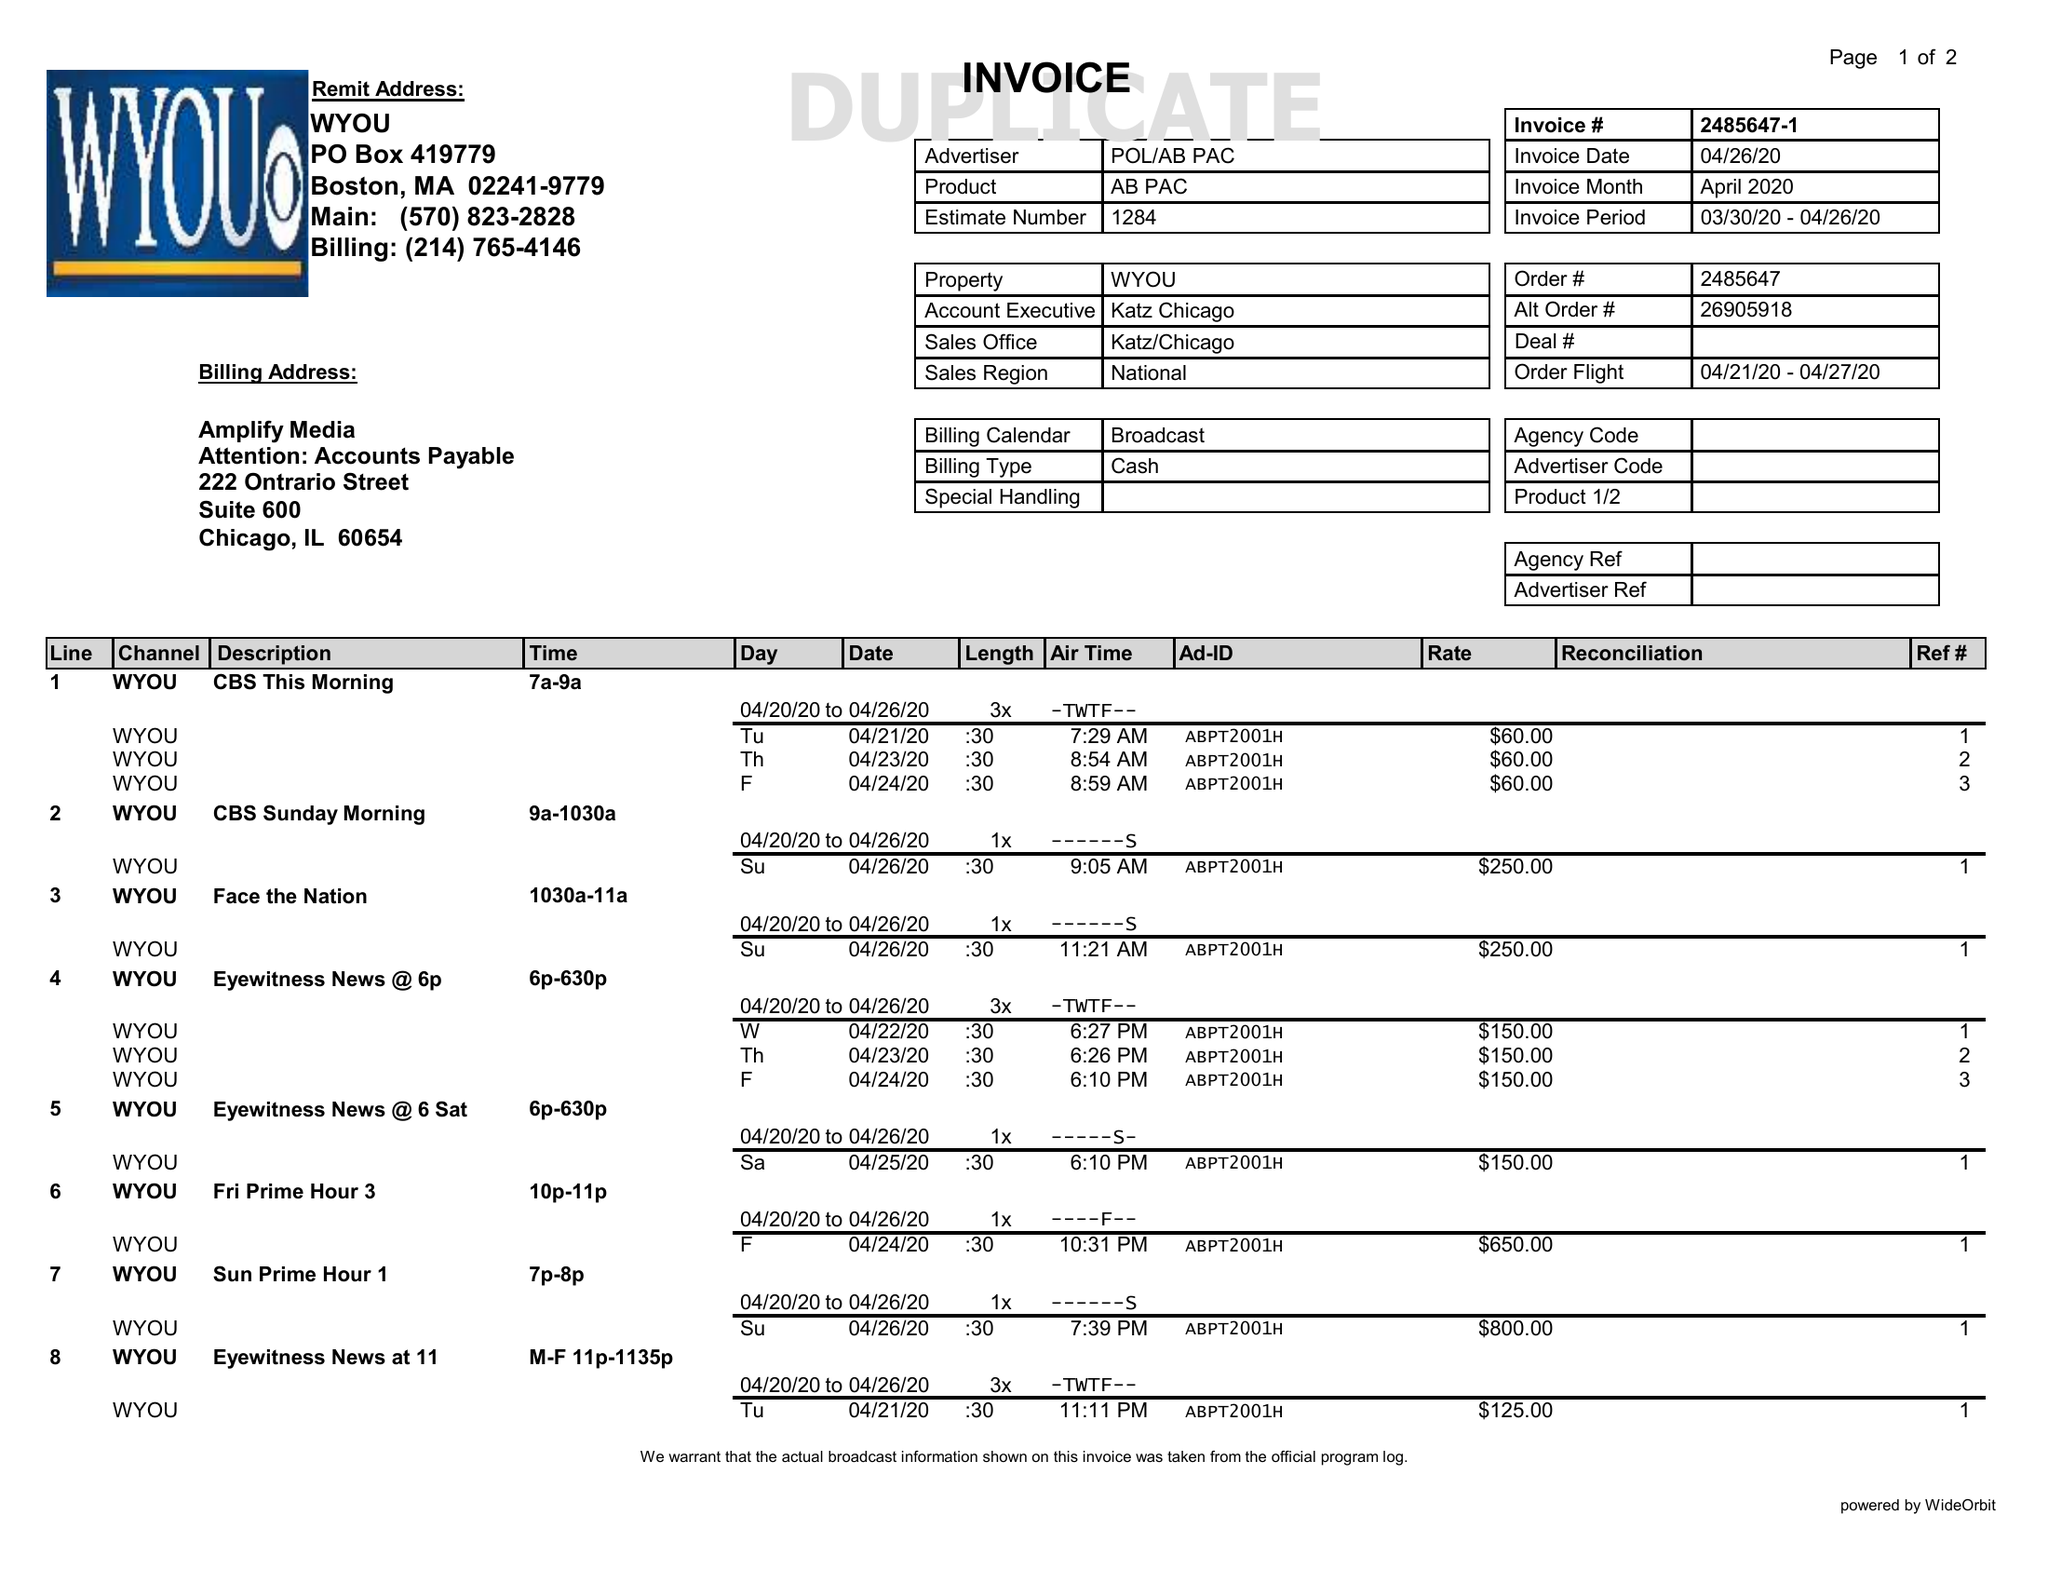What is the value for the advertiser?
Answer the question using a single word or phrase. POL/ABPAC 